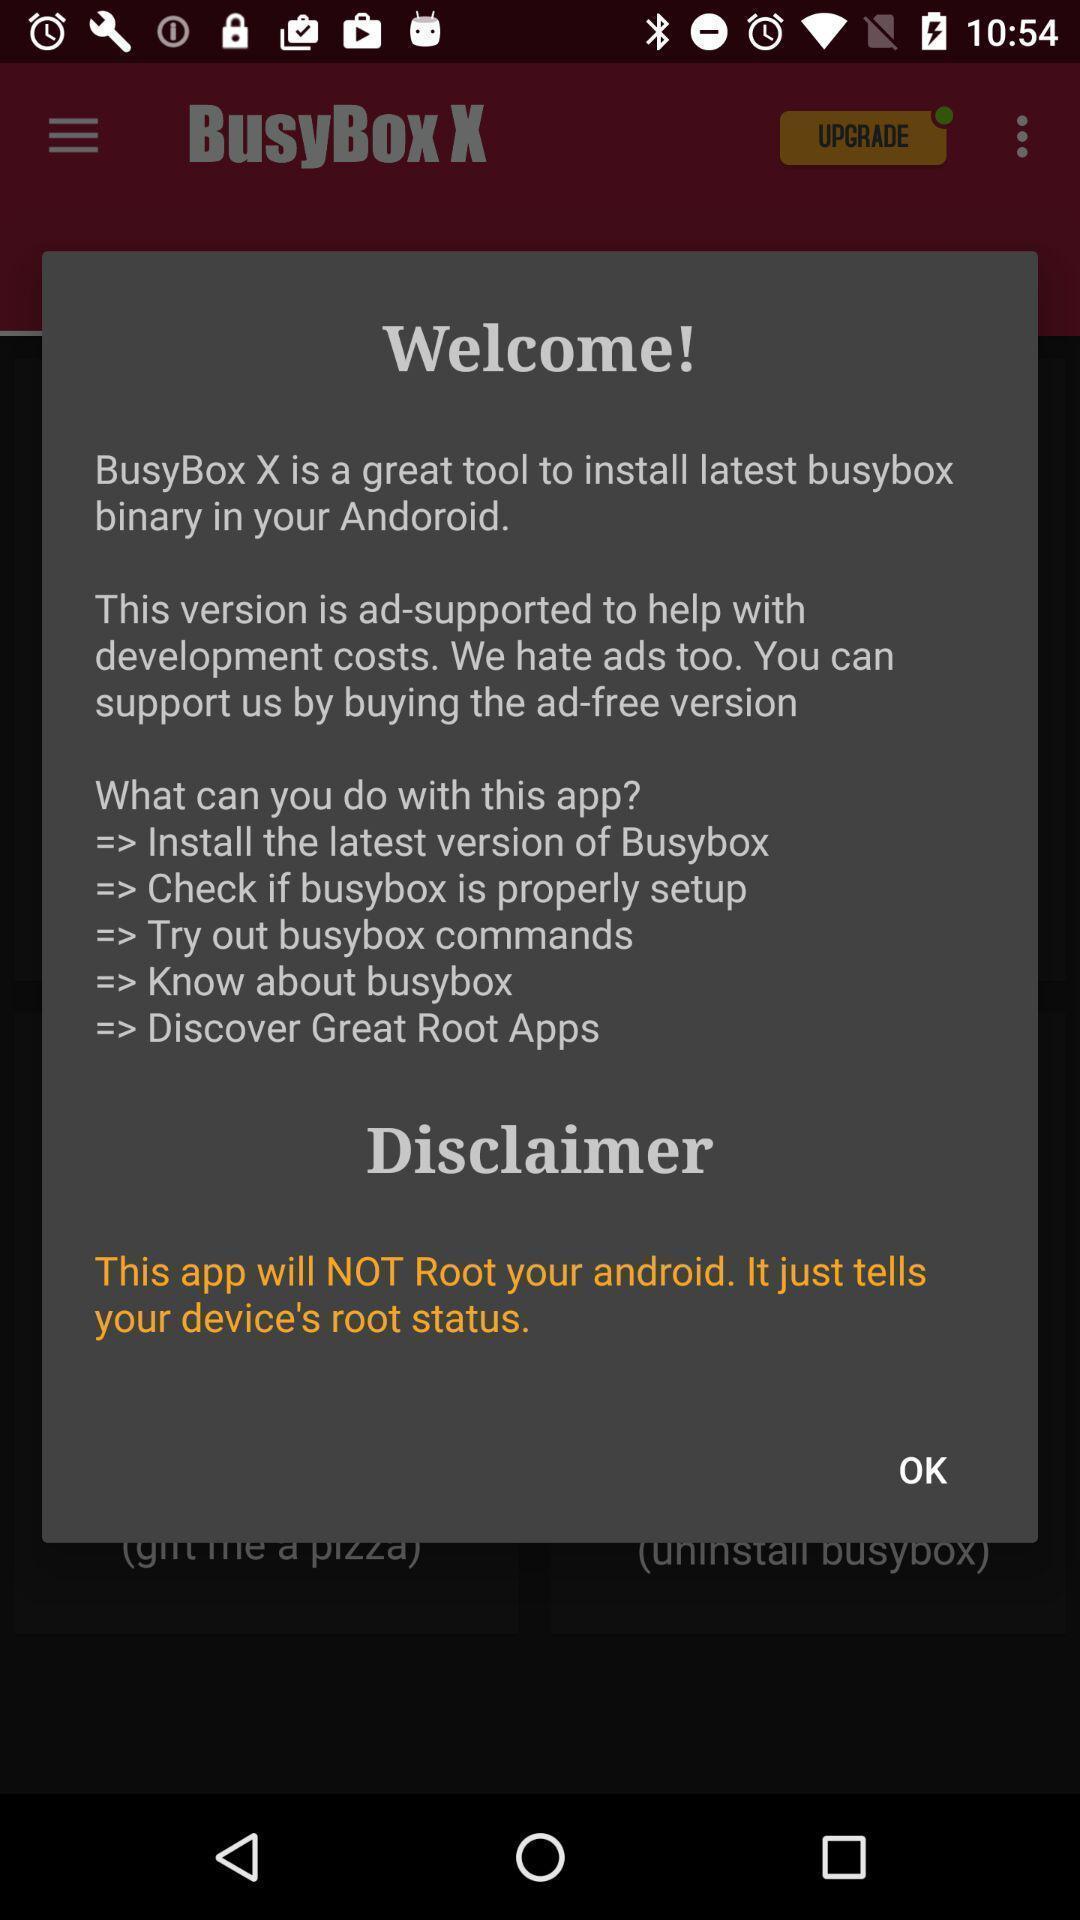Describe the visual elements of this screenshot. Welcome page with instructions on app. 